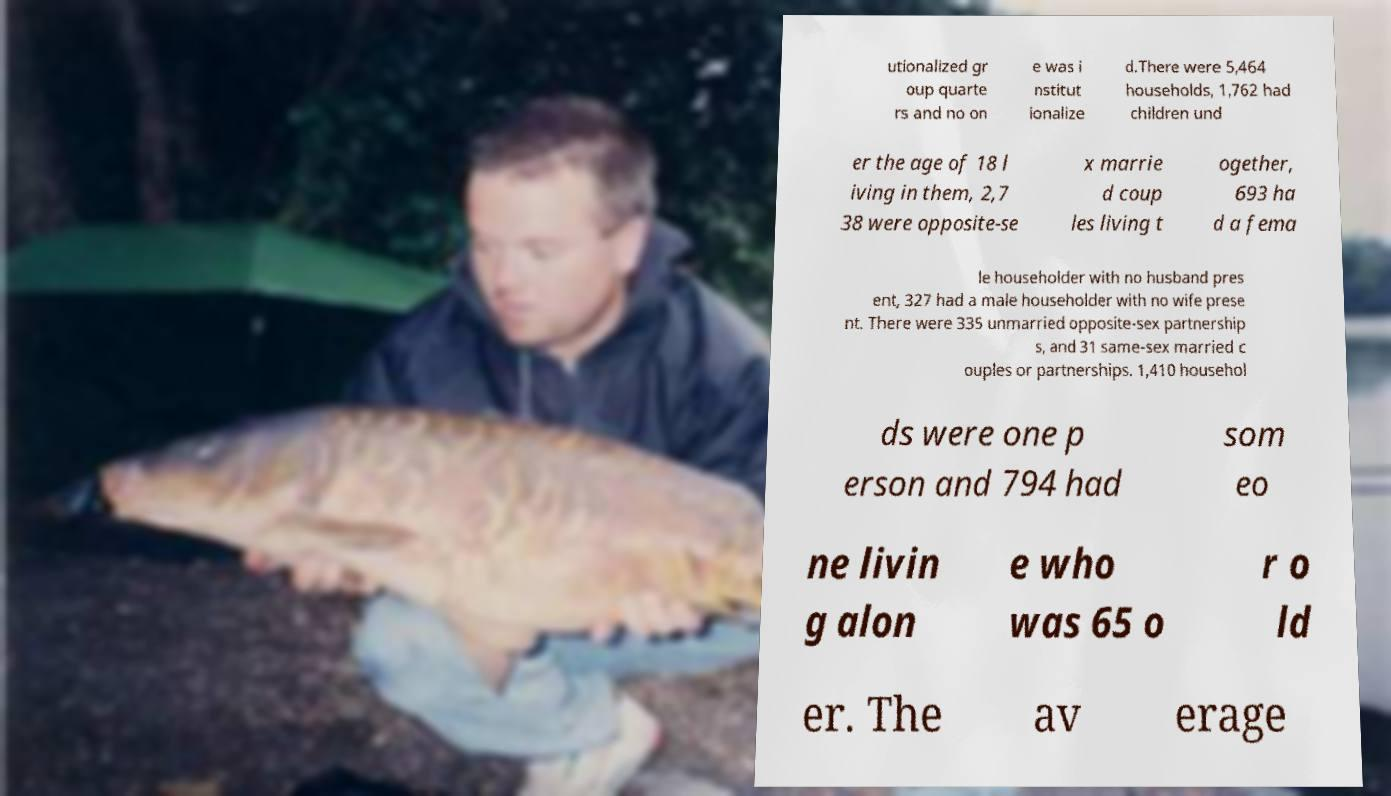Could you assist in decoding the text presented in this image and type it out clearly? utionalized gr oup quarte rs and no on e was i nstitut ionalize d.There were 5,464 households, 1,762 had children und er the age of 18 l iving in them, 2,7 38 were opposite-se x marrie d coup les living t ogether, 693 ha d a fema le householder with no husband pres ent, 327 had a male householder with no wife prese nt. There were 335 unmarried opposite-sex partnership s, and 31 same-sex married c ouples or partnerships. 1,410 househol ds were one p erson and 794 had som eo ne livin g alon e who was 65 o r o ld er. The av erage 